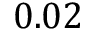Convert formula to latex. <formula><loc_0><loc_0><loc_500><loc_500>0 . 0 2</formula> 